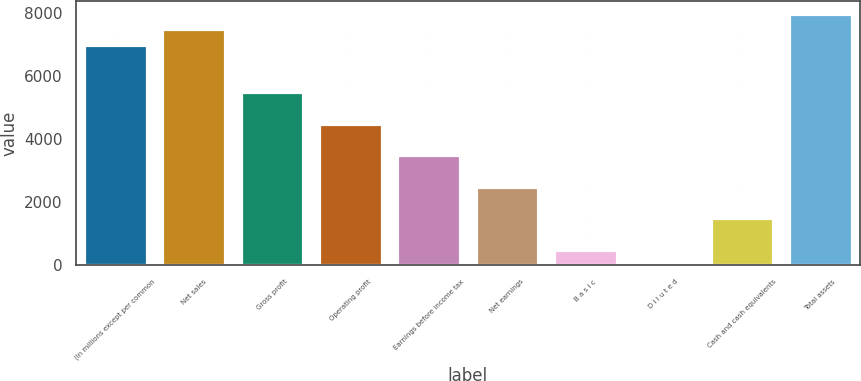Convert chart to OTSL. <chart><loc_0><loc_0><loc_500><loc_500><bar_chart><fcel>(In millions except per common<fcel>Net sales<fcel>Gross profit<fcel>Operating profit<fcel>Earnings before income tax<fcel>Net earnings<fcel>B a s i c<fcel>D i l u t e d<fcel>Cash and cash equivalents<fcel>Total assets<nl><fcel>6979.99<fcel>7478.49<fcel>5484.49<fcel>4487.49<fcel>3490.49<fcel>2493.49<fcel>499.49<fcel>0.99<fcel>1496.49<fcel>7976.99<nl></chart> 